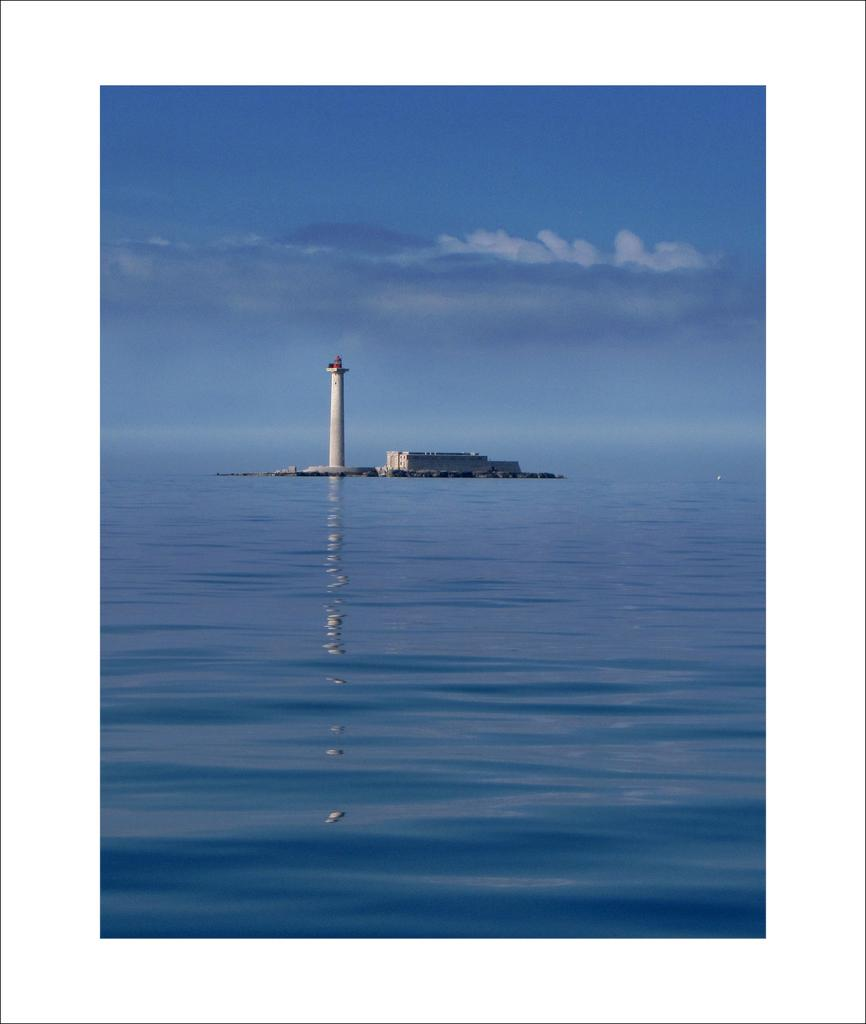What type of water is visible in the image? The water appears to be an ocean in the image. What structures can be seen in the background of the image? There is a building and a tower in the background of the image. What is visible at the top of the image? The sky is visible at the top of the image. What can be observed in the sky? Clouds are present in the sky. What type of dirt can be seen on the floor of the club in the image? There is no club or dirt present in the image; it features an ocean with a building and a tower in the background. 